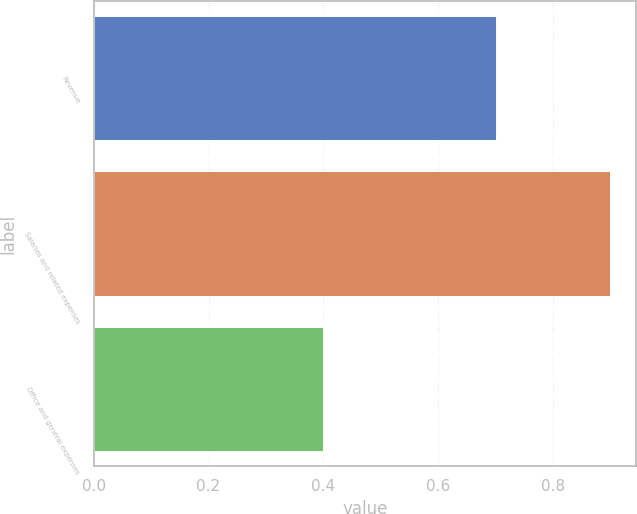Convert chart. <chart><loc_0><loc_0><loc_500><loc_500><bar_chart><fcel>Revenue<fcel>Salaries and related expenses<fcel>Office and general expenses<nl><fcel>0.7<fcel>0.9<fcel>0.4<nl></chart> 